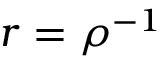<formula> <loc_0><loc_0><loc_500><loc_500>r = \rho ^ { - 1 }</formula> 